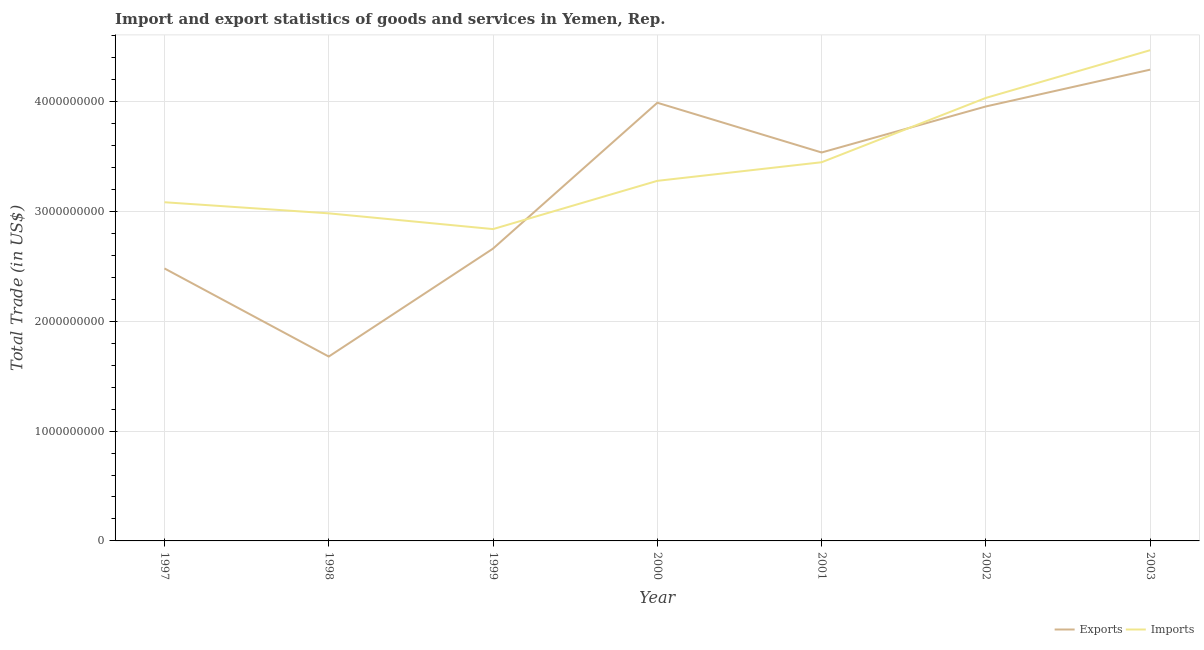Does the line corresponding to export of goods and services intersect with the line corresponding to imports of goods and services?
Your response must be concise. Yes. What is the export of goods and services in 2001?
Your response must be concise. 3.54e+09. Across all years, what is the maximum imports of goods and services?
Make the answer very short. 4.47e+09. Across all years, what is the minimum imports of goods and services?
Provide a succinct answer. 2.84e+09. In which year was the export of goods and services maximum?
Ensure brevity in your answer.  2003. In which year was the export of goods and services minimum?
Offer a very short reply. 1998. What is the total imports of goods and services in the graph?
Your response must be concise. 2.41e+1. What is the difference between the export of goods and services in 1998 and that in 2003?
Give a very brief answer. -2.61e+09. What is the difference between the export of goods and services in 1997 and the imports of goods and services in 2002?
Make the answer very short. -1.55e+09. What is the average imports of goods and services per year?
Keep it short and to the point. 3.45e+09. In the year 2000, what is the difference between the imports of goods and services and export of goods and services?
Keep it short and to the point. -7.11e+08. In how many years, is the imports of goods and services greater than 1200000000 US$?
Your response must be concise. 7. What is the ratio of the export of goods and services in 1997 to that in 1998?
Provide a short and direct response. 1.48. Is the imports of goods and services in 1999 less than that in 2001?
Provide a short and direct response. Yes. Is the difference between the imports of goods and services in 2000 and 2001 greater than the difference between the export of goods and services in 2000 and 2001?
Give a very brief answer. No. What is the difference between the highest and the second highest imports of goods and services?
Offer a very short reply. 4.34e+08. What is the difference between the highest and the lowest export of goods and services?
Offer a very short reply. 2.61e+09. Is the export of goods and services strictly less than the imports of goods and services over the years?
Make the answer very short. No. How many years are there in the graph?
Give a very brief answer. 7. Are the values on the major ticks of Y-axis written in scientific E-notation?
Give a very brief answer. No. Does the graph contain any zero values?
Provide a succinct answer. No. Where does the legend appear in the graph?
Offer a terse response. Bottom right. How many legend labels are there?
Offer a terse response. 2. What is the title of the graph?
Keep it short and to the point. Import and export statistics of goods and services in Yemen, Rep. What is the label or title of the Y-axis?
Provide a short and direct response. Total Trade (in US$). What is the Total Trade (in US$) of Exports in 1997?
Offer a very short reply. 2.48e+09. What is the Total Trade (in US$) of Imports in 1997?
Make the answer very short. 3.08e+09. What is the Total Trade (in US$) in Exports in 1998?
Ensure brevity in your answer.  1.68e+09. What is the Total Trade (in US$) in Imports in 1998?
Ensure brevity in your answer.  2.98e+09. What is the Total Trade (in US$) in Exports in 1999?
Keep it short and to the point. 2.66e+09. What is the Total Trade (in US$) of Imports in 1999?
Keep it short and to the point. 2.84e+09. What is the Total Trade (in US$) of Exports in 2000?
Offer a terse response. 3.99e+09. What is the Total Trade (in US$) in Imports in 2000?
Keep it short and to the point. 3.28e+09. What is the Total Trade (in US$) of Exports in 2001?
Offer a terse response. 3.54e+09. What is the Total Trade (in US$) in Imports in 2001?
Keep it short and to the point. 3.45e+09. What is the Total Trade (in US$) in Exports in 2002?
Your answer should be compact. 3.96e+09. What is the Total Trade (in US$) in Imports in 2002?
Provide a short and direct response. 4.03e+09. What is the Total Trade (in US$) in Exports in 2003?
Your answer should be very brief. 4.29e+09. What is the Total Trade (in US$) of Imports in 2003?
Offer a terse response. 4.47e+09. Across all years, what is the maximum Total Trade (in US$) in Exports?
Provide a succinct answer. 4.29e+09. Across all years, what is the maximum Total Trade (in US$) of Imports?
Provide a short and direct response. 4.47e+09. Across all years, what is the minimum Total Trade (in US$) in Exports?
Your answer should be very brief. 1.68e+09. Across all years, what is the minimum Total Trade (in US$) in Imports?
Ensure brevity in your answer.  2.84e+09. What is the total Total Trade (in US$) in Exports in the graph?
Your answer should be compact. 2.26e+1. What is the total Total Trade (in US$) in Imports in the graph?
Provide a short and direct response. 2.41e+1. What is the difference between the Total Trade (in US$) of Exports in 1997 and that in 1998?
Keep it short and to the point. 8.03e+08. What is the difference between the Total Trade (in US$) in Imports in 1997 and that in 1998?
Give a very brief answer. 1.01e+08. What is the difference between the Total Trade (in US$) in Exports in 1997 and that in 1999?
Offer a very short reply. -1.81e+08. What is the difference between the Total Trade (in US$) in Imports in 1997 and that in 1999?
Your response must be concise. 2.44e+08. What is the difference between the Total Trade (in US$) in Exports in 1997 and that in 2000?
Provide a short and direct response. -1.51e+09. What is the difference between the Total Trade (in US$) in Imports in 1997 and that in 2000?
Your answer should be compact. -1.95e+08. What is the difference between the Total Trade (in US$) of Exports in 1997 and that in 2001?
Provide a succinct answer. -1.06e+09. What is the difference between the Total Trade (in US$) in Imports in 1997 and that in 2001?
Your answer should be compact. -3.64e+08. What is the difference between the Total Trade (in US$) in Exports in 1997 and that in 2002?
Your response must be concise. -1.48e+09. What is the difference between the Total Trade (in US$) in Imports in 1997 and that in 2002?
Your response must be concise. -9.50e+08. What is the difference between the Total Trade (in US$) in Exports in 1997 and that in 2003?
Your answer should be compact. -1.81e+09. What is the difference between the Total Trade (in US$) in Imports in 1997 and that in 2003?
Your answer should be compact. -1.38e+09. What is the difference between the Total Trade (in US$) of Exports in 1998 and that in 1999?
Your answer should be compact. -9.83e+08. What is the difference between the Total Trade (in US$) in Imports in 1998 and that in 1999?
Offer a very short reply. 1.43e+08. What is the difference between the Total Trade (in US$) of Exports in 1998 and that in 2000?
Make the answer very short. -2.31e+09. What is the difference between the Total Trade (in US$) in Imports in 1998 and that in 2000?
Provide a short and direct response. -2.96e+08. What is the difference between the Total Trade (in US$) in Exports in 1998 and that in 2001?
Keep it short and to the point. -1.86e+09. What is the difference between the Total Trade (in US$) in Imports in 1998 and that in 2001?
Provide a succinct answer. -4.65e+08. What is the difference between the Total Trade (in US$) of Exports in 1998 and that in 2002?
Your response must be concise. -2.28e+09. What is the difference between the Total Trade (in US$) in Imports in 1998 and that in 2002?
Your answer should be compact. -1.05e+09. What is the difference between the Total Trade (in US$) in Exports in 1998 and that in 2003?
Ensure brevity in your answer.  -2.61e+09. What is the difference between the Total Trade (in US$) in Imports in 1998 and that in 2003?
Your answer should be very brief. -1.49e+09. What is the difference between the Total Trade (in US$) in Exports in 1999 and that in 2000?
Your answer should be very brief. -1.33e+09. What is the difference between the Total Trade (in US$) of Imports in 1999 and that in 2000?
Your answer should be very brief. -4.39e+08. What is the difference between the Total Trade (in US$) of Exports in 1999 and that in 2001?
Ensure brevity in your answer.  -8.75e+08. What is the difference between the Total Trade (in US$) in Imports in 1999 and that in 2001?
Give a very brief answer. -6.09e+08. What is the difference between the Total Trade (in US$) in Exports in 1999 and that in 2002?
Your answer should be compact. -1.29e+09. What is the difference between the Total Trade (in US$) of Imports in 1999 and that in 2002?
Make the answer very short. -1.19e+09. What is the difference between the Total Trade (in US$) of Exports in 1999 and that in 2003?
Your answer should be compact. -1.63e+09. What is the difference between the Total Trade (in US$) of Imports in 1999 and that in 2003?
Your answer should be very brief. -1.63e+09. What is the difference between the Total Trade (in US$) of Exports in 2000 and that in 2001?
Keep it short and to the point. 4.53e+08. What is the difference between the Total Trade (in US$) in Imports in 2000 and that in 2001?
Give a very brief answer. -1.69e+08. What is the difference between the Total Trade (in US$) of Exports in 2000 and that in 2002?
Offer a very short reply. 3.37e+07. What is the difference between the Total Trade (in US$) of Imports in 2000 and that in 2002?
Give a very brief answer. -7.55e+08. What is the difference between the Total Trade (in US$) of Exports in 2000 and that in 2003?
Ensure brevity in your answer.  -3.01e+08. What is the difference between the Total Trade (in US$) of Imports in 2000 and that in 2003?
Offer a very short reply. -1.19e+09. What is the difference between the Total Trade (in US$) of Exports in 2001 and that in 2002?
Make the answer very short. -4.19e+08. What is the difference between the Total Trade (in US$) of Imports in 2001 and that in 2002?
Make the answer very short. -5.86e+08. What is the difference between the Total Trade (in US$) in Exports in 2001 and that in 2003?
Ensure brevity in your answer.  -7.54e+08. What is the difference between the Total Trade (in US$) in Imports in 2001 and that in 2003?
Your answer should be compact. -1.02e+09. What is the difference between the Total Trade (in US$) in Exports in 2002 and that in 2003?
Give a very brief answer. -3.35e+08. What is the difference between the Total Trade (in US$) in Imports in 2002 and that in 2003?
Your response must be concise. -4.34e+08. What is the difference between the Total Trade (in US$) in Exports in 1997 and the Total Trade (in US$) in Imports in 1998?
Your answer should be compact. -5.02e+08. What is the difference between the Total Trade (in US$) in Exports in 1997 and the Total Trade (in US$) in Imports in 1999?
Ensure brevity in your answer.  -3.58e+08. What is the difference between the Total Trade (in US$) of Exports in 1997 and the Total Trade (in US$) of Imports in 2000?
Your response must be concise. -7.98e+08. What is the difference between the Total Trade (in US$) of Exports in 1997 and the Total Trade (in US$) of Imports in 2001?
Offer a terse response. -9.67e+08. What is the difference between the Total Trade (in US$) in Exports in 1997 and the Total Trade (in US$) in Imports in 2002?
Your answer should be compact. -1.55e+09. What is the difference between the Total Trade (in US$) of Exports in 1997 and the Total Trade (in US$) of Imports in 2003?
Make the answer very short. -1.99e+09. What is the difference between the Total Trade (in US$) in Exports in 1998 and the Total Trade (in US$) in Imports in 1999?
Provide a short and direct response. -1.16e+09. What is the difference between the Total Trade (in US$) in Exports in 1998 and the Total Trade (in US$) in Imports in 2000?
Provide a short and direct response. -1.60e+09. What is the difference between the Total Trade (in US$) in Exports in 1998 and the Total Trade (in US$) in Imports in 2001?
Your answer should be very brief. -1.77e+09. What is the difference between the Total Trade (in US$) of Exports in 1998 and the Total Trade (in US$) of Imports in 2002?
Your answer should be compact. -2.36e+09. What is the difference between the Total Trade (in US$) of Exports in 1998 and the Total Trade (in US$) of Imports in 2003?
Keep it short and to the point. -2.79e+09. What is the difference between the Total Trade (in US$) in Exports in 1999 and the Total Trade (in US$) in Imports in 2000?
Provide a succinct answer. -6.17e+08. What is the difference between the Total Trade (in US$) of Exports in 1999 and the Total Trade (in US$) of Imports in 2001?
Provide a succinct answer. -7.86e+08. What is the difference between the Total Trade (in US$) in Exports in 1999 and the Total Trade (in US$) in Imports in 2002?
Provide a short and direct response. -1.37e+09. What is the difference between the Total Trade (in US$) of Exports in 1999 and the Total Trade (in US$) of Imports in 2003?
Your response must be concise. -1.81e+09. What is the difference between the Total Trade (in US$) of Exports in 2000 and the Total Trade (in US$) of Imports in 2001?
Give a very brief answer. 5.42e+08. What is the difference between the Total Trade (in US$) in Exports in 2000 and the Total Trade (in US$) in Imports in 2002?
Your answer should be very brief. -4.42e+07. What is the difference between the Total Trade (in US$) of Exports in 2000 and the Total Trade (in US$) of Imports in 2003?
Offer a very short reply. -4.79e+08. What is the difference between the Total Trade (in US$) of Exports in 2001 and the Total Trade (in US$) of Imports in 2002?
Keep it short and to the point. -4.97e+08. What is the difference between the Total Trade (in US$) in Exports in 2001 and the Total Trade (in US$) in Imports in 2003?
Provide a succinct answer. -9.32e+08. What is the difference between the Total Trade (in US$) in Exports in 2002 and the Total Trade (in US$) in Imports in 2003?
Keep it short and to the point. -5.12e+08. What is the average Total Trade (in US$) of Exports per year?
Offer a terse response. 3.23e+09. What is the average Total Trade (in US$) of Imports per year?
Your response must be concise. 3.45e+09. In the year 1997, what is the difference between the Total Trade (in US$) of Exports and Total Trade (in US$) of Imports?
Provide a succinct answer. -6.03e+08. In the year 1998, what is the difference between the Total Trade (in US$) in Exports and Total Trade (in US$) in Imports?
Provide a succinct answer. -1.30e+09. In the year 1999, what is the difference between the Total Trade (in US$) of Exports and Total Trade (in US$) of Imports?
Offer a very short reply. -1.78e+08. In the year 2000, what is the difference between the Total Trade (in US$) of Exports and Total Trade (in US$) of Imports?
Ensure brevity in your answer.  7.11e+08. In the year 2001, what is the difference between the Total Trade (in US$) of Exports and Total Trade (in US$) of Imports?
Give a very brief answer. 8.88e+07. In the year 2002, what is the difference between the Total Trade (in US$) in Exports and Total Trade (in US$) in Imports?
Keep it short and to the point. -7.79e+07. In the year 2003, what is the difference between the Total Trade (in US$) in Exports and Total Trade (in US$) in Imports?
Provide a short and direct response. -1.77e+08. What is the ratio of the Total Trade (in US$) in Exports in 1997 to that in 1998?
Offer a terse response. 1.48. What is the ratio of the Total Trade (in US$) in Imports in 1997 to that in 1998?
Your answer should be compact. 1.03. What is the ratio of the Total Trade (in US$) of Exports in 1997 to that in 1999?
Give a very brief answer. 0.93. What is the ratio of the Total Trade (in US$) in Imports in 1997 to that in 1999?
Ensure brevity in your answer.  1.09. What is the ratio of the Total Trade (in US$) in Exports in 1997 to that in 2000?
Keep it short and to the point. 0.62. What is the ratio of the Total Trade (in US$) in Imports in 1997 to that in 2000?
Keep it short and to the point. 0.94. What is the ratio of the Total Trade (in US$) of Exports in 1997 to that in 2001?
Your answer should be compact. 0.7. What is the ratio of the Total Trade (in US$) of Imports in 1997 to that in 2001?
Offer a very short reply. 0.89. What is the ratio of the Total Trade (in US$) in Exports in 1997 to that in 2002?
Ensure brevity in your answer.  0.63. What is the ratio of the Total Trade (in US$) in Imports in 1997 to that in 2002?
Give a very brief answer. 0.76. What is the ratio of the Total Trade (in US$) of Exports in 1997 to that in 2003?
Your answer should be very brief. 0.58. What is the ratio of the Total Trade (in US$) of Imports in 1997 to that in 2003?
Offer a very short reply. 0.69. What is the ratio of the Total Trade (in US$) in Exports in 1998 to that in 1999?
Offer a very short reply. 0.63. What is the ratio of the Total Trade (in US$) of Imports in 1998 to that in 1999?
Provide a short and direct response. 1.05. What is the ratio of the Total Trade (in US$) of Exports in 1998 to that in 2000?
Offer a terse response. 0.42. What is the ratio of the Total Trade (in US$) in Imports in 1998 to that in 2000?
Offer a terse response. 0.91. What is the ratio of the Total Trade (in US$) in Exports in 1998 to that in 2001?
Offer a very short reply. 0.47. What is the ratio of the Total Trade (in US$) in Imports in 1998 to that in 2001?
Provide a short and direct response. 0.87. What is the ratio of the Total Trade (in US$) of Exports in 1998 to that in 2002?
Give a very brief answer. 0.42. What is the ratio of the Total Trade (in US$) of Imports in 1998 to that in 2002?
Give a very brief answer. 0.74. What is the ratio of the Total Trade (in US$) in Exports in 1998 to that in 2003?
Your answer should be compact. 0.39. What is the ratio of the Total Trade (in US$) of Imports in 1998 to that in 2003?
Offer a terse response. 0.67. What is the ratio of the Total Trade (in US$) in Exports in 1999 to that in 2000?
Your answer should be very brief. 0.67. What is the ratio of the Total Trade (in US$) in Imports in 1999 to that in 2000?
Make the answer very short. 0.87. What is the ratio of the Total Trade (in US$) of Exports in 1999 to that in 2001?
Provide a succinct answer. 0.75. What is the ratio of the Total Trade (in US$) in Imports in 1999 to that in 2001?
Provide a short and direct response. 0.82. What is the ratio of the Total Trade (in US$) in Exports in 1999 to that in 2002?
Keep it short and to the point. 0.67. What is the ratio of the Total Trade (in US$) in Imports in 1999 to that in 2002?
Your response must be concise. 0.7. What is the ratio of the Total Trade (in US$) of Exports in 1999 to that in 2003?
Ensure brevity in your answer.  0.62. What is the ratio of the Total Trade (in US$) in Imports in 1999 to that in 2003?
Your answer should be compact. 0.64. What is the ratio of the Total Trade (in US$) in Exports in 2000 to that in 2001?
Ensure brevity in your answer.  1.13. What is the ratio of the Total Trade (in US$) in Imports in 2000 to that in 2001?
Give a very brief answer. 0.95. What is the ratio of the Total Trade (in US$) in Exports in 2000 to that in 2002?
Give a very brief answer. 1.01. What is the ratio of the Total Trade (in US$) in Imports in 2000 to that in 2002?
Make the answer very short. 0.81. What is the ratio of the Total Trade (in US$) of Exports in 2000 to that in 2003?
Your answer should be very brief. 0.93. What is the ratio of the Total Trade (in US$) of Imports in 2000 to that in 2003?
Keep it short and to the point. 0.73. What is the ratio of the Total Trade (in US$) of Exports in 2001 to that in 2002?
Provide a short and direct response. 0.89. What is the ratio of the Total Trade (in US$) of Imports in 2001 to that in 2002?
Make the answer very short. 0.85. What is the ratio of the Total Trade (in US$) in Exports in 2001 to that in 2003?
Offer a very short reply. 0.82. What is the ratio of the Total Trade (in US$) of Imports in 2001 to that in 2003?
Ensure brevity in your answer.  0.77. What is the ratio of the Total Trade (in US$) in Exports in 2002 to that in 2003?
Offer a very short reply. 0.92. What is the ratio of the Total Trade (in US$) of Imports in 2002 to that in 2003?
Ensure brevity in your answer.  0.9. What is the difference between the highest and the second highest Total Trade (in US$) of Exports?
Your answer should be compact. 3.01e+08. What is the difference between the highest and the second highest Total Trade (in US$) of Imports?
Ensure brevity in your answer.  4.34e+08. What is the difference between the highest and the lowest Total Trade (in US$) of Exports?
Your answer should be very brief. 2.61e+09. What is the difference between the highest and the lowest Total Trade (in US$) of Imports?
Your response must be concise. 1.63e+09. 